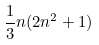Convert formula to latex. <formula><loc_0><loc_0><loc_500><loc_500>\frac { 1 } { 3 } n ( 2 n ^ { 2 } + 1 )</formula> 